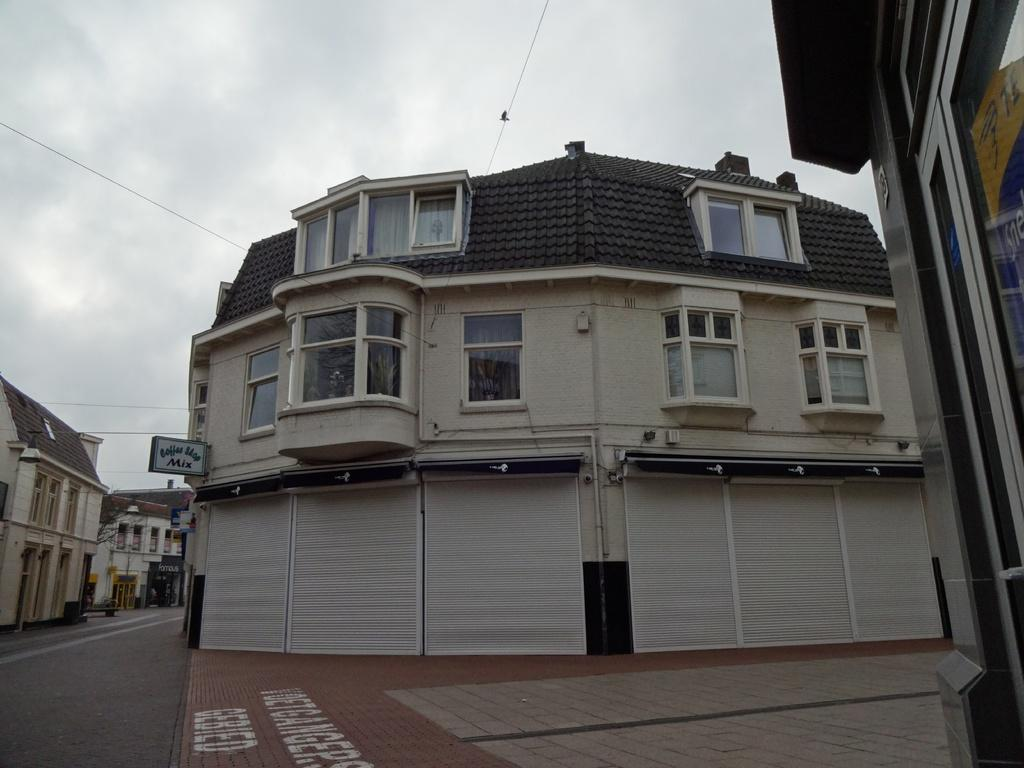What type of structures can be seen in the image? There are buildings in the image. What are the name boards used for in the image? The name boards are used to identify the buildings or locations in the image. What else can be seen in the image besides buildings and name boards? There are trees and the sky visible in the image. What is the condition of the sky in the image? The sky is visible in the image, and clouds are present. Can you tell me how many grapes are hanging from the trees in the image? There are no grapes present in the image; it features buildings, name boards, trees, and the sky. 